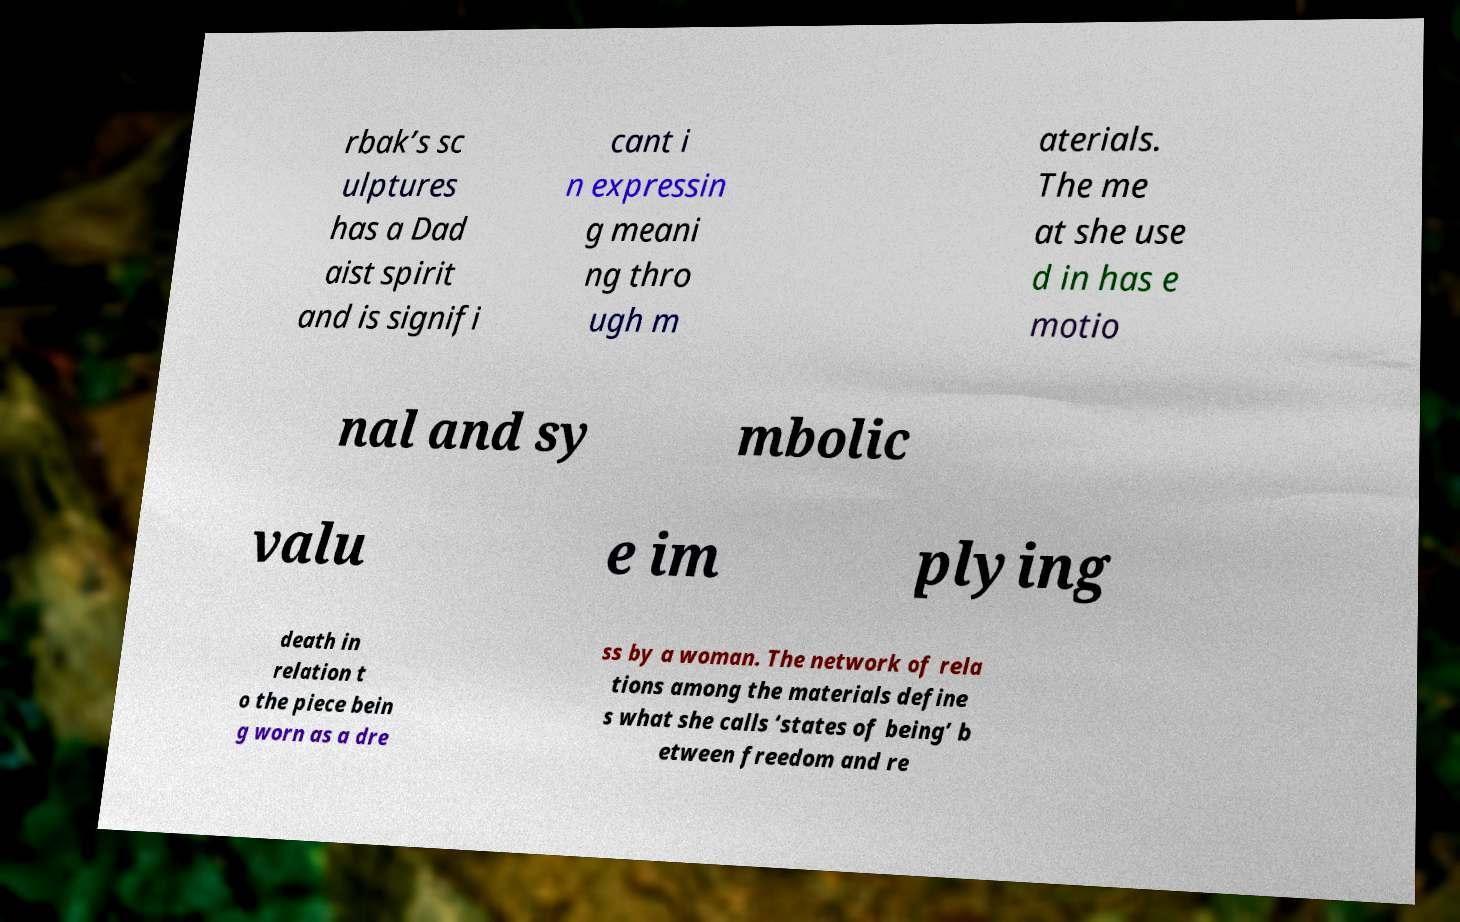What messages or text are displayed in this image? I need them in a readable, typed format. rbak’s sc ulptures has a Dad aist spirit and is signifi cant i n expressin g meani ng thro ugh m aterials. The me at she use d in has e motio nal and sy mbolic valu e im plying death in relation t o the piece bein g worn as a dre ss by a woman. The network of rela tions among the materials define s what she calls ‘states of being’ b etween freedom and re 